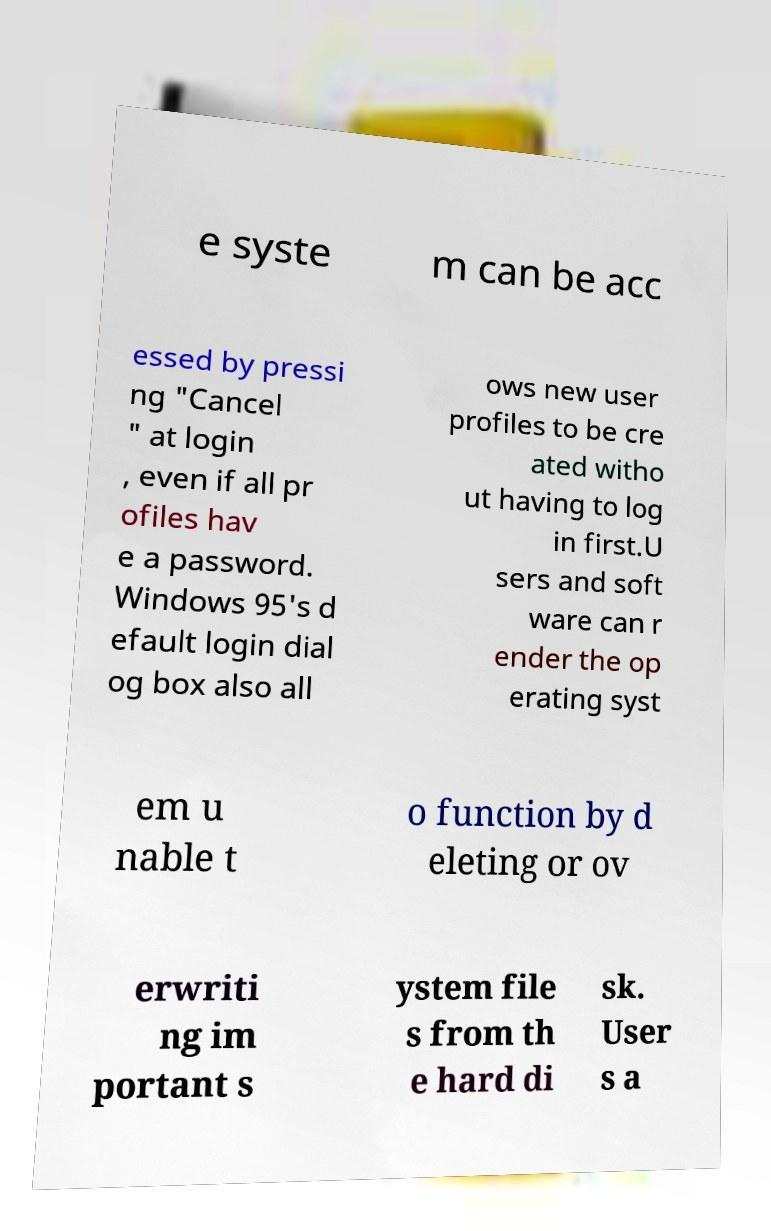Could you assist in decoding the text presented in this image and type it out clearly? e syste m can be acc essed by pressi ng "Cancel " at login , even if all pr ofiles hav e a password. Windows 95's d efault login dial og box also all ows new user profiles to be cre ated witho ut having to log in first.U sers and soft ware can r ender the op erating syst em u nable t o function by d eleting or ov erwriti ng im portant s ystem file s from th e hard di sk. User s a 